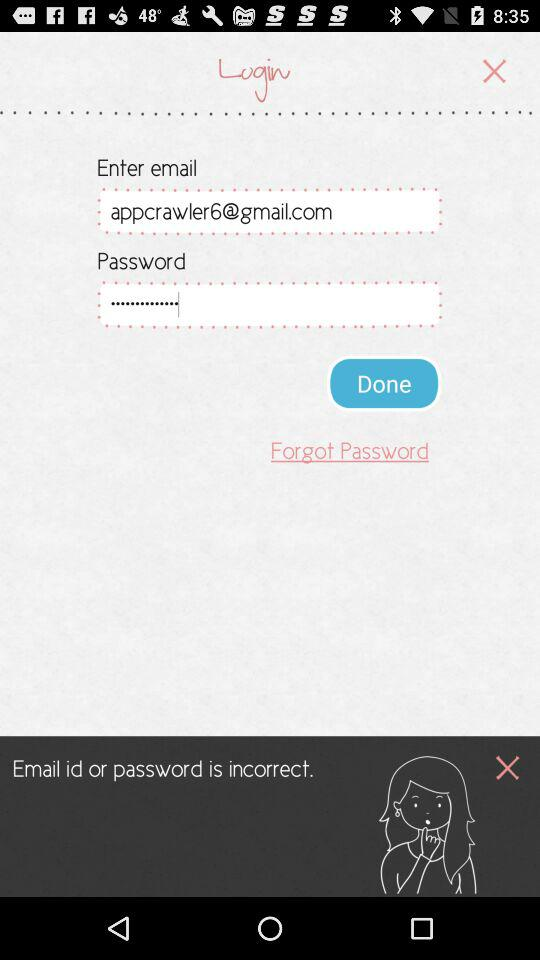What is an email address? The email address is appcrawler6@gmail.com. 